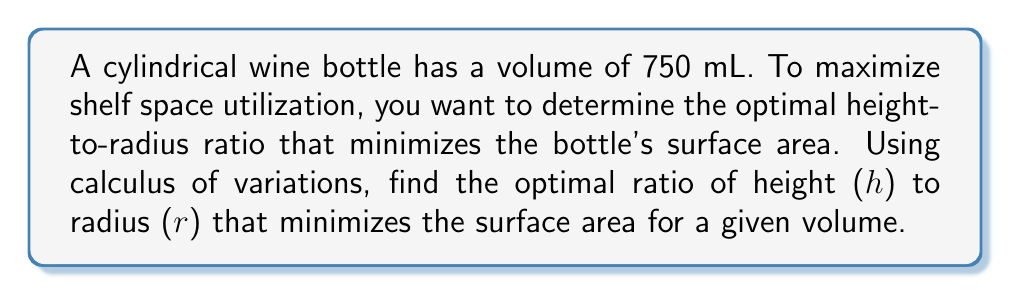Give your solution to this math problem. 1) The volume of a cylinder is given by:
   $$V = \pi r^2 h$$

2) The surface area of a cylinder (including top and bottom) is:
   $$S = 2\pi r^2 + 2\pi r h$$

3) We want to minimize S subject to the constraint that V is constant (750 mL).

4) Form the functional:
   $$F = S + \lambda(V - 750)$$
   $$F = 2\pi r^2 + 2\pi r h + \lambda(\pi r^2 h - 750)$$

5) Take partial derivatives and set them to zero:
   $$\frac{\partial F}{\partial r} = 4\pi r + 2\pi h + \lambda(2\pi r h) = 0$$
   $$\frac{\partial F}{\partial h} = 2\pi r + \lambda(\pi r^2) = 0$$

6) From the second equation:
   $$\lambda = -\frac{2}{r}$$

7) Substitute into the first equation:
   $$4\pi r + 2\pi h - 4\pi h = 0$$
   $$4r - 2h = 0$$
   $$h = 2r$$

8) This means the optimal height is twice the radius.

9) The height-to-radius ratio is therefore 2:1.
Answer: 2:1 